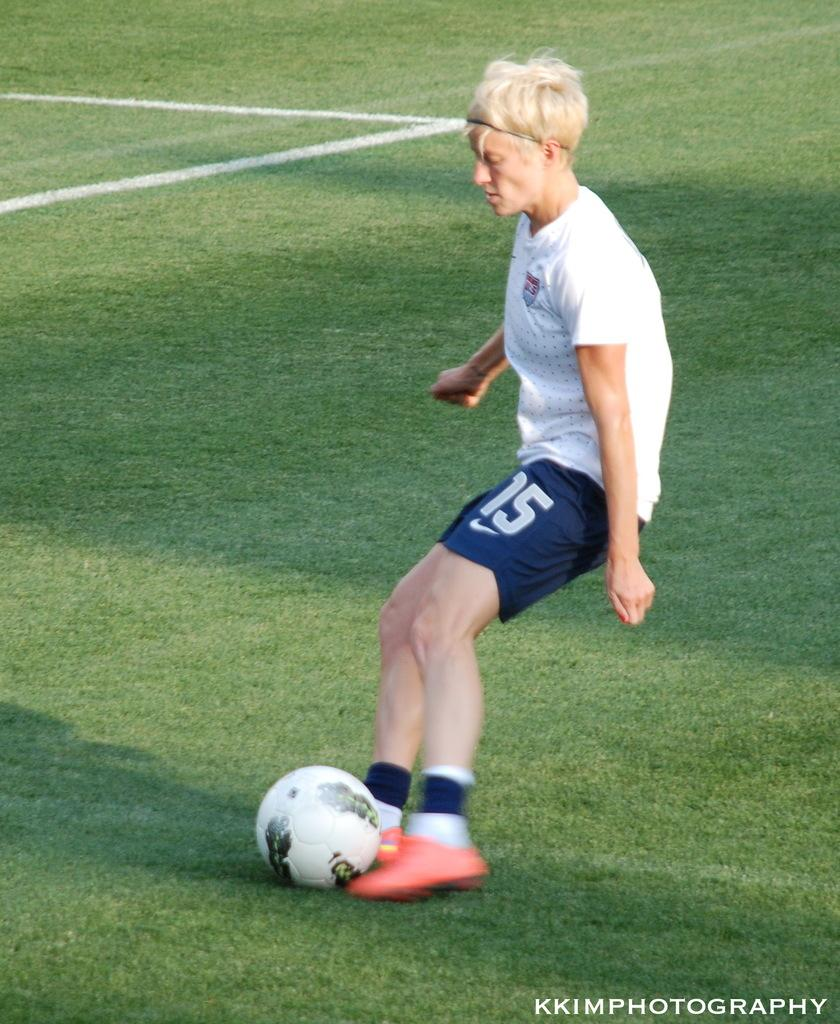What is the person in the image doing? The person is playing with a ball. What type of surface is visible in the image? There is grass in the image. What type of grip does the drum have in the image? There is no drum present in the image. 